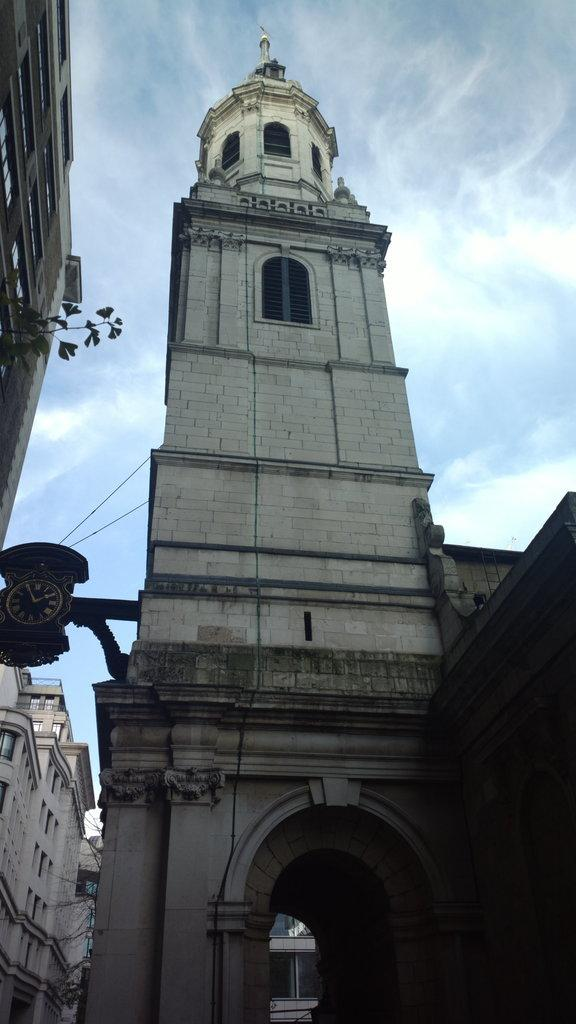What structures are located in the foreground of the image? There are buildings and towers in the foreground of the image. What can be seen in the background of the image? The sky is visible in the background of the image. When was the image taken? The image was taken during the day. What type of pain is the person experiencing in the image? There is no person present in the image, and therefore no indication of any pain. Can you tell me how many tomatoes are visible in the image? There are no tomatoes present in the image. 